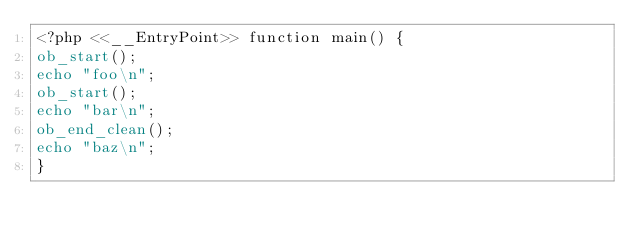<code> <loc_0><loc_0><loc_500><loc_500><_PHP_><?php <<__EntryPoint>> function main() {
ob_start();
echo "foo\n";
ob_start();
echo "bar\n";
ob_end_clean();
echo "baz\n";
}
</code> 